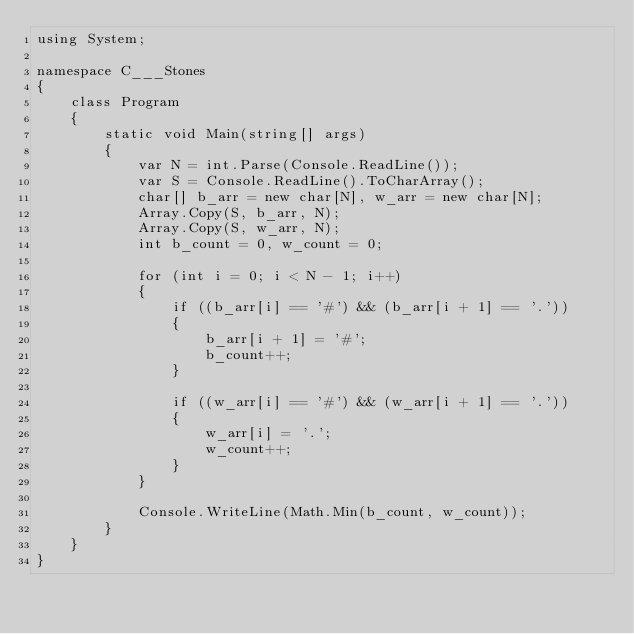<code> <loc_0><loc_0><loc_500><loc_500><_C#_>using System;

namespace C___Stones
{
    class Program
    {
        static void Main(string[] args)
        {
            var N = int.Parse(Console.ReadLine());
            var S = Console.ReadLine().ToCharArray();
            char[] b_arr = new char[N], w_arr = new char[N];
            Array.Copy(S, b_arr, N);
            Array.Copy(S, w_arr, N);
            int b_count = 0, w_count = 0;

            for (int i = 0; i < N - 1; i++)
            {
                if ((b_arr[i] == '#') && (b_arr[i + 1] == '.'))
                {
                    b_arr[i + 1] = '#';
                    b_count++;
                }

                if ((w_arr[i] == '#') && (w_arr[i + 1] == '.'))
                {
                    w_arr[i] = '.';
                    w_count++;
                }
            }

            Console.WriteLine(Math.Min(b_count, w_count));
        }
    }
}
</code> 